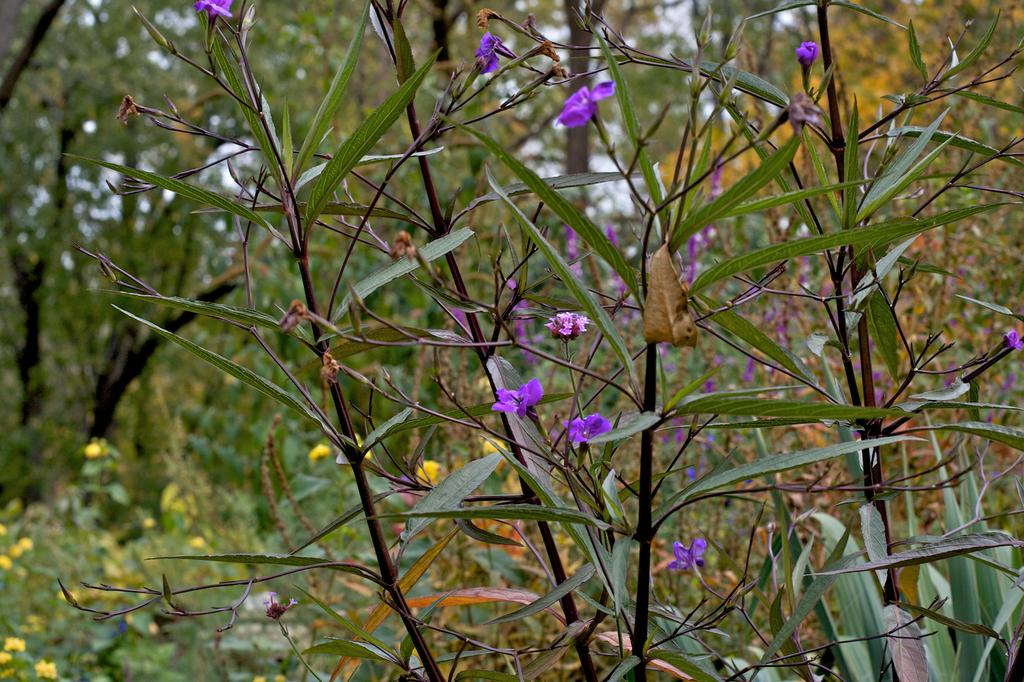What type of plants can be seen in the image? There are plants with flowers in the image. What color are the flowers on the plants? The flowers are purple in color. What can be seen in the background of the image? There are trees in the background of the image. Where are the yellow flowers located in the image? The yellow flowers are at the bottom left of the image. Can you hear the deer crying in the image? There are no deer or any sounds mentioned in the image, so it is not possible to answer that question. 